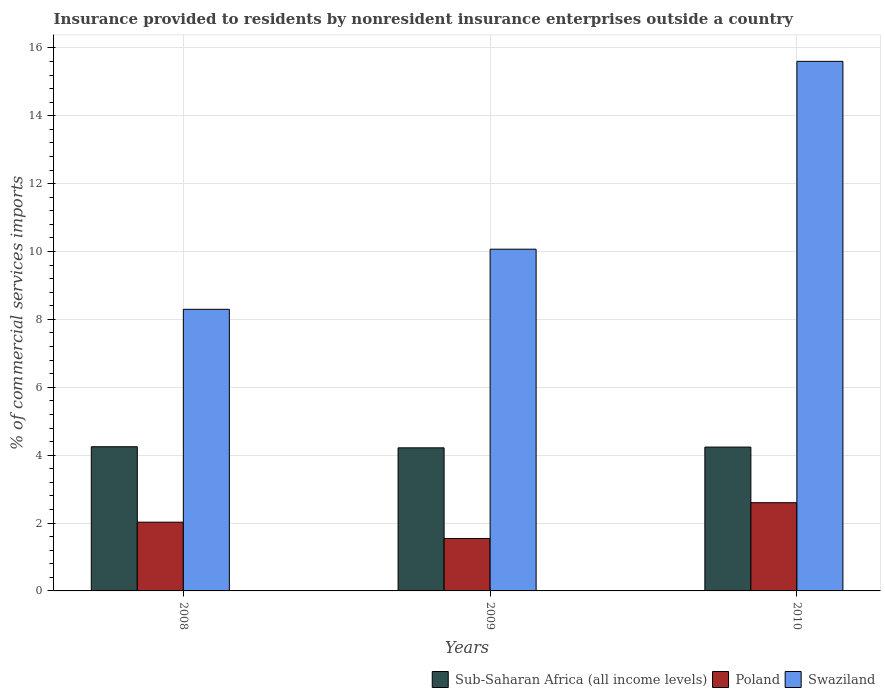How many bars are there on the 1st tick from the left?
Offer a terse response. 3. What is the Insurance provided to residents in Sub-Saharan Africa (all income levels) in 2009?
Your answer should be very brief. 4.22. Across all years, what is the maximum Insurance provided to residents in Poland?
Your response must be concise. 2.6. Across all years, what is the minimum Insurance provided to residents in Sub-Saharan Africa (all income levels)?
Provide a succinct answer. 4.22. In which year was the Insurance provided to residents in Swaziland minimum?
Your answer should be compact. 2008. What is the total Insurance provided to residents in Poland in the graph?
Ensure brevity in your answer.  6.17. What is the difference between the Insurance provided to residents in Swaziland in 2008 and that in 2010?
Your answer should be very brief. -7.31. What is the difference between the Insurance provided to residents in Sub-Saharan Africa (all income levels) in 2008 and the Insurance provided to residents in Swaziland in 2010?
Offer a terse response. -11.36. What is the average Insurance provided to residents in Sub-Saharan Africa (all income levels) per year?
Keep it short and to the point. 4.23. In the year 2010, what is the difference between the Insurance provided to residents in Swaziland and Insurance provided to residents in Poland?
Give a very brief answer. 13. What is the ratio of the Insurance provided to residents in Sub-Saharan Africa (all income levels) in 2009 to that in 2010?
Provide a succinct answer. 0.99. Is the Insurance provided to residents in Swaziland in 2008 less than that in 2010?
Give a very brief answer. Yes. What is the difference between the highest and the second highest Insurance provided to residents in Poland?
Ensure brevity in your answer.  0.57. What is the difference between the highest and the lowest Insurance provided to residents in Swaziland?
Make the answer very short. 7.31. In how many years, is the Insurance provided to residents in Poland greater than the average Insurance provided to residents in Poland taken over all years?
Offer a terse response. 1. What does the 2nd bar from the left in 2009 represents?
Keep it short and to the point. Poland. Is it the case that in every year, the sum of the Insurance provided to residents in Poland and Insurance provided to residents in Sub-Saharan Africa (all income levels) is greater than the Insurance provided to residents in Swaziland?
Your response must be concise. No. How many bars are there?
Give a very brief answer. 9. Are all the bars in the graph horizontal?
Provide a succinct answer. No. How many years are there in the graph?
Your response must be concise. 3. Does the graph contain any zero values?
Provide a short and direct response. No. Does the graph contain grids?
Ensure brevity in your answer.  Yes. Where does the legend appear in the graph?
Your answer should be very brief. Bottom right. What is the title of the graph?
Make the answer very short. Insurance provided to residents by nonresident insurance enterprises outside a country. Does "Mexico" appear as one of the legend labels in the graph?
Your response must be concise. No. What is the label or title of the Y-axis?
Your answer should be very brief. % of commercial services imports. What is the % of commercial services imports in Sub-Saharan Africa (all income levels) in 2008?
Offer a very short reply. 4.25. What is the % of commercial services imports in Poland in 2008?
Offer a terse response. 2.03. What is the % of commercial services imports in Swaziland in 2008?
Ensure brevity in your answer.  8.3. What is the % of commercial services imports of Sub-Saharan Africa (all income levels) in 2009?
Offer a very short reply. 4.22. What is the % of commercial services imports in Poland in 2009?
Offer a terse response. 1.55. What is the % of commercial services imports in Swaziland in 2009?
Keep it short and to the point. 10.07. What is the % of commercial services imports of Sub-Saharan Africa (all income levels) in 2010?
Ensure brevity in your answer.  4.24. What is the % of commercial services imports of Poland in 2010?
Give a very brief answer. 2.6. What is the % of commercial services imports of Swaziland in 2010?
Make the answer very short. 15.6. Across all years, what is the maximum % of commercial services imports in Sub-Saharan Africa (all income levels)?
Offer a terse response. 4.25. Across all years, what is the maximum % of commercial services imports in Poland?
Your answer should be very brief. 2.6. Across all years, what is the maximum % of commercial services imports of Swaziland?
Your response must be concise. 15.6. Across all years, what is the minimum % of commercial services imports of Sub-Saharan Africa (all income levels)?
Your answer should be very brief. 4.22. Across all years, what is the minimum % of commercial services imports in Poland?
Your answer should be very brief. 1.55. Across all years, what is the minimum % of commercial services imports of Swaziland?
Provide a succinct answer. 8.3. What is the total % of commercial services imports of Sub-Saharan Africa (all income levels) in the graph?
Make the answer very short. 12.7. What is the total % of commercial services imports of Poland in the graph?
Your response must be concise. 6.17. What is the total % of commercial services imports of Swaziland in the graph?
Your response must be concise. 33.97. What is the difference between the % of commercial services imports of Sub-Saharan Africa (all income levels) in 2008 and that in 2009?
Offer a terse response. 0.03. What is the difference between the % of commercial services imports of Poland in 2008 and that in 2009?
Your response must be concise. 0.48. What is the difference between the % of commercial services imports of Swaziland in 2008 and that in 2009?
Your answer should be compact. -1.77. What is the difference between the % of commercial services imports in Sub-Saharan Africa (all income levels) in 2008 and that in 2010?
Provide a succinct answer. 0.01. What is the difference between the % of commercial services imports of Poland in 2008 and that in 2010?
Provide a succinct answer. -0.57. What is the difference between the % of commercial services imports of Swaziland in 2008 and that in 2010?
Offer a very short reply. -7.31. What is the difference between the % of commercial services imports of Sub-Saharan Africa (all income levels) in 2009 and that in 2010?
Ensure brevity in your answer.  -0.02. What is the difference between the % of commercial services imports of Poland in 2009 and that in 2010?
Provide a short and direct response. -1.05. What is the difference between the % of commercial services imports in Swaziland in 2009 and that in 2010?
Ensure brevity in your answer.  -5.53. What is the difference between the % of commercial services imports in Sub-Saharan Africa (all income levels) in 2008 and the % of commercial services imports in Poland in 2009?
Keep it short and to the point. 2.7. What is the difference between the % of commercial services imports of Sub-Saharan Africa (all income levels) in 2008 and the % of commercial services imports of Swaziland in 2009?
Ensure brevity in your answer.  -5.82. What is the difference between the % of commercial services imports in Poland in 2008 and the % of commercial services imports in Swaziland in 2009?
Ensure brevity in your answer.  -8.04. What is the difference between the % of commercial services imports of Sub-Saharan Africa (all income levels) in 2008 and the % of commercial services imports of Poland in 2010?
Your answer should be compact. 1.65. What is the difference between the % of commercial services imports of Sub-Saharan Africa (all income levels) in 2008 and the % of commercial services imports of Swaziland in 2010?
Provide a succinct answer. -11.36. What is the difference between the % of commercial services imports in Poland in 2008 and the % of commercial services imports in Swaziland in 2010?
Give a very brief answer. -13.58. What is the difference between the % of commercial services imports in Sub-Saharan Africa (all income levels) in 2009 and the % of commercial services imports in Poland in 2010?
Keep it short and to the point. 1.62. What is the difference between the % of commercial services imports of Sub-Saharan Africa (all income levels) in 2009 and the % of commercial services imports of Swaziland in 2010?
Your answer should be very brief. -11.39. What is the difference between the % of commercial services imports of Poland in 2009 and the % of commercial services imports of Swaziland in 2010?
Give a very brief answer. -14.06. What is the average % of commercial services imports in Sub-Saharan Africa (all income levels) per year?
Give a very brief answer. 4.23. What is the average % of commercial services imports of Poland per year?
Your answer should be very brief. 2.06. What is the average % of commercial services imports of Swaziland per year?
Your answer should be very brief. 11.32. In the year 2008, what is the difference between the % of commercial services imports of Sub-Saharan Africa (all income levels) and % of commercial services imports of Poland?
Offer a terse response. 2.22. In the year 2008, what is the difference between the % of commercial services imports of Sub-Saharan Africa (all income levels) and % of commercial services imports of Swaziland?
Offer a terse response. -4.05. In the year 2008, what is the difference between the % of commercial services imports of Poland and % of commercial services imports of Swaziland?
Offer a very short reply. -6.27. In the year 2009, what is the difference between the % of commercial services imports of Sub-Saharan Africa (all income levels) and % of commercial services imports of Poland?
Ensure brevity in your answer.  2.67. In the year 2009, what is the difference between the % of commercial services imports of Sub-Saharan Africa (all income levels) and % of commercial services imports of Swaziland?
Provide a short and direct response. -5.85. In the year 2009, what is the difference between the % of commercial services imports in Poland and % of commercial services imports in Swaziland?
Offer a very short reply. -8.52. In the year 2010, what is the difference between the % of commercial services imports in Sub-Saharan Africa (all income levels) and % of commercial services imports in Poland?
Your response must be concise. 1.64. In the year 2010, what is the difference between the % of commercial services imports of Sub-Saharan Africa (all income levels) and % of commercial services imports of Swaziland?
Keep it short and to the point. -11.37. In the year 2010, what is the difference between the % of commercial services imports in Poland and % of commercial services imports in Swaziland?
Ensure brevity in your answer.  -13. What is the ratio of the % of commercial services imports of Sub-Saharan Africa (all income levels) in 2008 to that in 2009?
Provide a short and direct response. 1.01. What is the ratio of the % of commercial services imports in Poland in 2008 to that in 2009?
Make the answer very short. 1.31. What is the ratio of the % of commercial services imports in Swaziland in 2008 to that in 2009?
Provide a short and direct response. 0.82. What is the ratio of the % of commercial services imports in Sub-Saharan Africa (all income levels) in 2008 to that in 2010?
Your response must be concise. 1. What is the ratio of the % of commercial services imports in Poland in 2008 to that in 2010?
Give a very brief answer. 0.78. What is the ratio of the % of commercial services imports of Swaziland in 2008 to that in 2010?
Offer a terse response. 0.53. What is the ratio of the % of commercial services imports of Poland in 2009 to that in 2010?
Keep it short and to the point. 0.59. What is the ratio of the % of commercial services imports of Swaziland in 2009 to that in 2010?
Make the answer very short. 0.65. What is the difference between the highest and the second highest % of commercial services imports in Sub-Saharan Africa (all income levels)?
Ensure brevity in your answer.  0.01. What is the difference between the highest and the second highest % of commercial services imports in Poland?
Your answer should be compact. 0.57. What is the difference between the highest and the second highest % of commercial services imports of Swaziland?
Your response must be concise. 5.53. What is the difference between the highest and the lowest % of commercial services imports of Sub-Saharan Africa (all income levels)?
Make the answer very short. 0.03. What is the difference between the highest and the lowest % of commercial services imports of Poland?
Ensure brevity in your answer.  1.05. What is the difference between the highest and the lowest % of commercial services imports in Swaziland?
Keep it short and to the point. 7.31. 